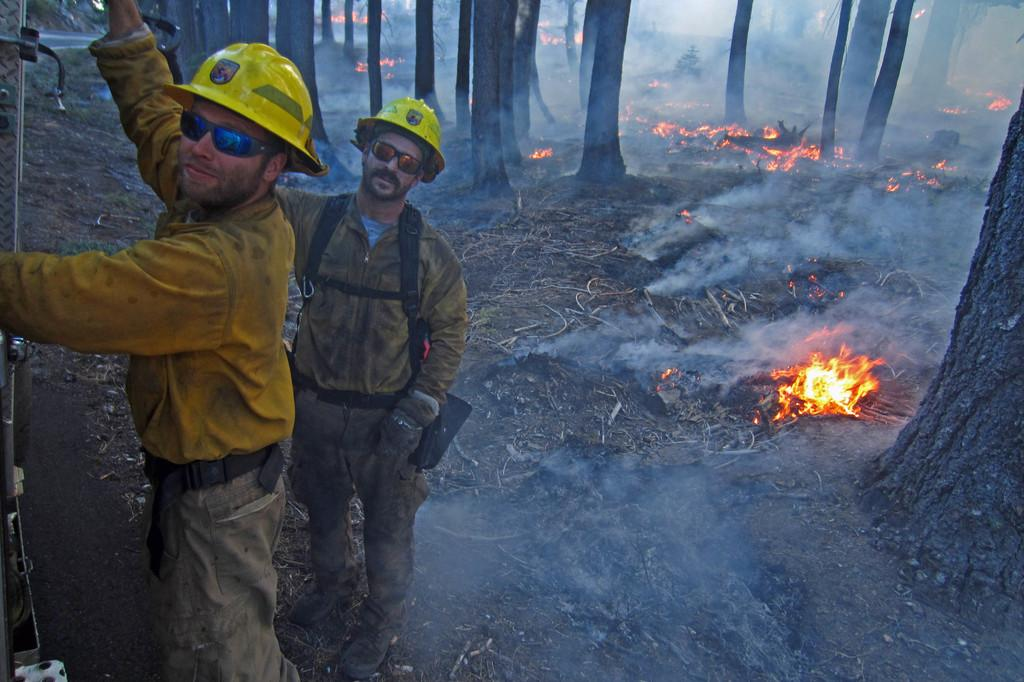Who is present in the image? There are men in the image. What are the men wearing on their faces? The men are wearing sunglasses. What type of headwear are the men wearing? The men are wearing caps. What can be seen in the background of the image? There are trees visible in the image. What is happening on the ground in the image? There is fire on the ground in the image. What type of shoes are the men wearing on their toes in the image? There is no mention of shoes or toes in the image; the men are wearing caps and sunglasses. Is there a church visible in the image? No, there is no church present in the image; only trees are visible in the background. 